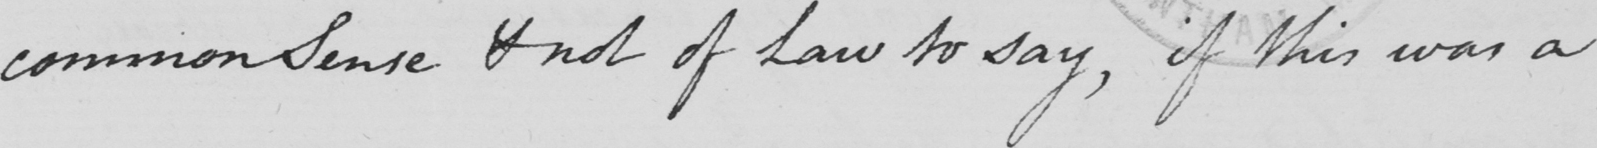Can you tell me what this handwritten text says? common Sense & not of Law to say , if this was a 